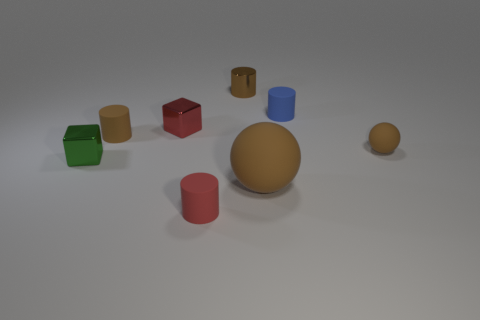What is the largest object in the image? The largest object in the image is the gold-colored sphere towards the center. 